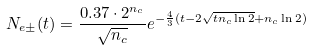<formula> <loc_0><loc_0><loc_500><loc_500>N _ { e \pm } ( t ) = \frac { 0 . 3 7 \cdot 2 ^ { n _ { c } } } { \sqrt { n _ { c } } } e ^ { - \frac { 4 } { 3 } ( t - 2 \sqrt { t n _ { c } \ln 2 } + n _ { c } \ln 2 ) }</formula> 